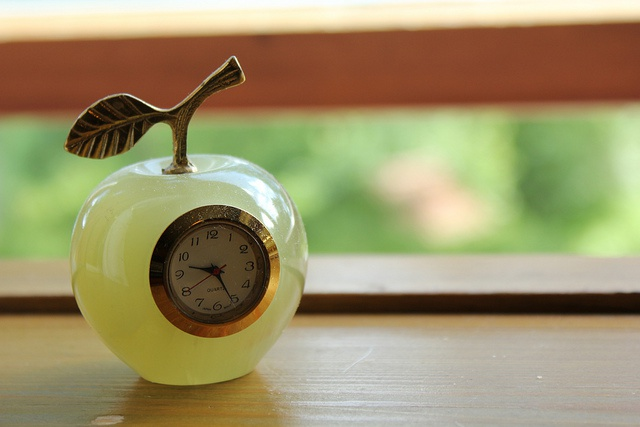Describe the objects in this image and their specific colors. I can see apple in white, olive, and black tones and clock in white, black, maroon, and olive tones in this image. 